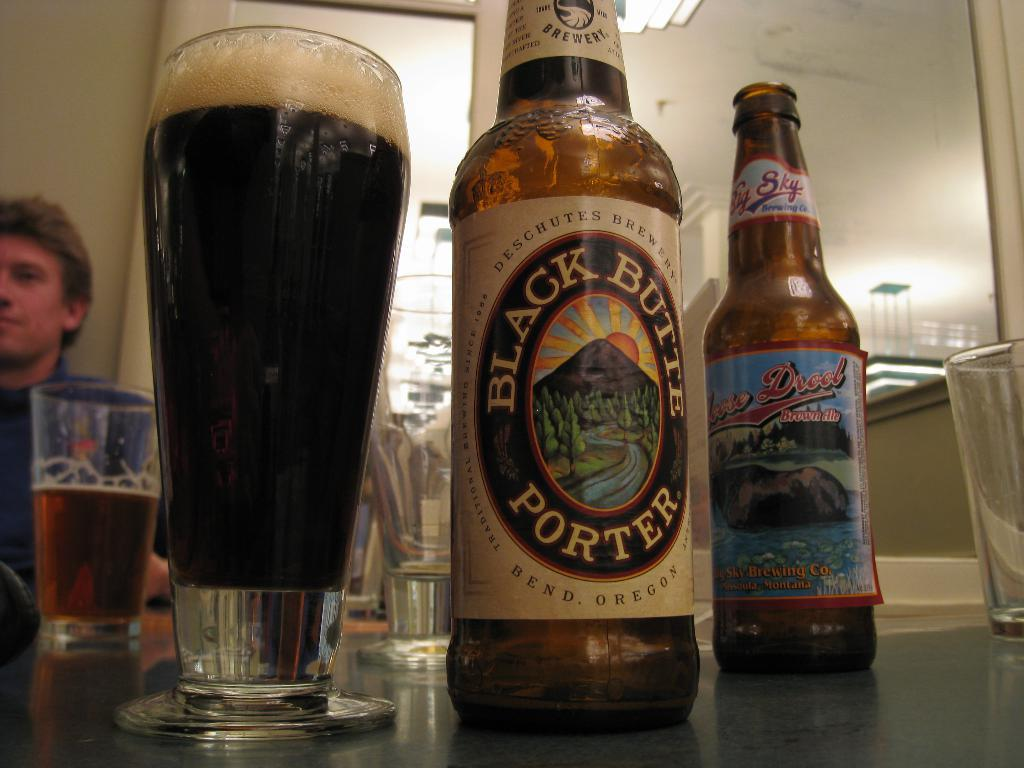How many bottles are visible in the image? There are two bottles in the image. What else can be seen in the image besides the bottles? There are glasses with liquid in the image. Can you describe the person in the image? There is a person sitting on the left side of the image. What type of shoes is the person wearing in the image? There is no information about the person's shoes in the image, as the focus is on the bottles and glasses. 